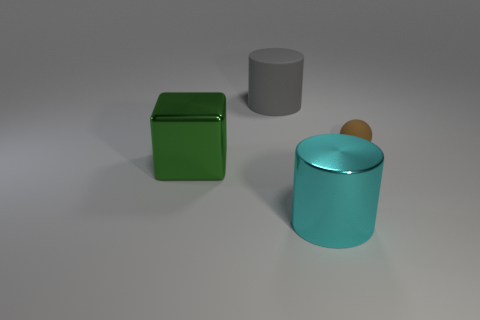Is there anything else that is the same shape as the small object?
Provide a succinct answer. No. What is the thing that is both behind the big metallic block and right of the large gray object made of?
Your answer should be compact. Rubber. There is a cylinder that is behind the brown thing; is it the same color as the object that is on the right side of the metallic cylinder?
Offer a very short reply. No. What number of yellow things are either metal cubes or metallic balls?
Give a very brief answer. 0. Are there fewer tiny spheres on the left side of the brown matte object than big cyan cylinders that are on the right side of the green block?
Your answer should be very brief. Yes. Are there any rubber objects of the same size as the gray rubber cylinder?
Keep it short and to the point. No. There is a cylinder that is behind the green metal thing; is its size the same as the big green metal block?
Offer a terse response. Yes. Is the number of gray shiny blocks greater than the number of green metallic blocks?
Your answer should be very brief. No. Are there any big gray rubber objects of the same shape as the green thing?
Your answer should be compact. No. There is a big thing that is on the left side of the large gray rubber thing; what is its shape?
Ensure brevity in your answer.  Cube. 